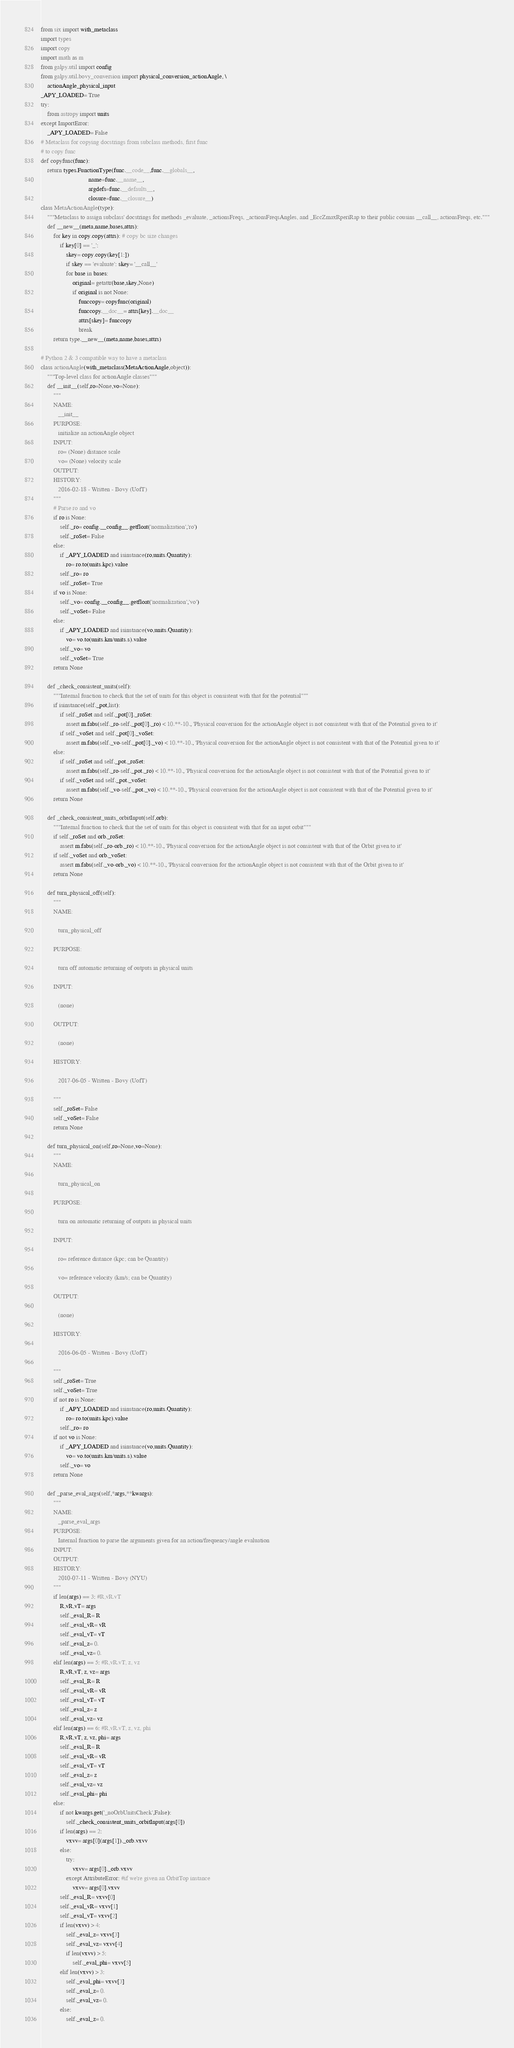Convert code to text. <code><loc_0><loc_0><loc_500><loc_500><_Python_>from six import with_metaclass
import types
import copy
import math as m
from galpy.util import config
from galpy.util.bovy_conversion import physical_conversion_actionAngle, \
    actionAngle_physical_input
_APY_LOADED= True
try:
    from astropy import units
except ImportError:
    _APY_LOADED= False
# Metaclass for copying docstrings from subclass methods, first func 
# to copy func
def copyfunc(func):
    return types.FunctionType(func.__code__,func.__globals__,
                              name=func.__name__,
                              argdefs=func.__defaults__,
                              closure=func.__closure__)
class MetaActionAngle(type):
    """Metaclass to assign subclass' docstrings for methods _evaluate, _actionsFreqs, _actionsFreqsAngles, and _EccZmaxRperiRap to their public cousins __call__, actionsFreqs, etc."""
    def __new__(meta,name,bases,attrs):
        for key in copy.copy(attrs): # copy bc size changes
            if key[0] == '_':
                skey= copy.copy(key[1:])
                if skey == 'evaluate': skey= '__call__'
                for base in bases:
                    original= getattr(base,skey,None)
                    if original is not None:
                        funccopy= copyfunc(original)
                        funccopy.__doc__= attrs[key].__doc__
                        attrs[skey]= funccopy
                        break
        return type.__new__(meta,name,bases,attrs)

# Python 2 & 3 compatible way to have a metaclass
class actionAngle(with_metaclass(MetaActionAngle,object)):
    """Top-level class for actionAngle classes"""
    def __init__(self,ro=None,vo=None):
        """
        NAME:
           __init__
        PURPOSE:
           initialize an actionAngle object
        INPUT:
           ro= (None) distance scale
           vo= (None) velocity scale
        OUTPUT:
        HISTORY:
           2016-02-18 - Written - Bovy (UofT)
        """
        # Parse ro and vo
        if ro is None:
            self._ro= config.__config__.getfloat('normalization','ro')
            self._roSet= False
        else:
            if _APY_LOADED and isinstance(ro,units.Quantity):
                ro= ro.to(units.kpc).value
            self._ro= ro
            self._roSet= True
        if vo is None:
            self._vo= config.__config__.getfloat('normalization','vo')
            self._voSet= False
        else:
            if _APY_LOADED and isinstance(vo,units.Quantity):
                vo= vo.to(units.km/units.s).value
            self._vo= vo
            self._voSet= True
        return None

    def _check_consistent_units(self):
        """Internal function to check that the set of units for this object is consistent with that for the potential"""
        if isinstance(self._pot,list):
            if self._roSet and self._pot[0]._roSet:
                assert m.fabs(self._ro-self._pot[0]._ro) < 10.**-10., 'Physical conversion for the actionAngle object is not consistent with that of the Potential given to it'
            if self._voSet and self._pot[0]._voSet:
                assert m.fabs(self._vo-self._pot[0]._vo) < 10.**-10., 'Physical conversion for the actionAngle object is not consistent with that of the Potential given to it'
        else:
            if self._roSet and self._pot._roSet:
                assert m.fabs(self._ro-self._pot._ro) < 10.**-10., 'Physical conversion for the actionAngle object is not consistent with that of the Potential given to it'
            if self._voSet and self._pot._voSet:
                assert m.fabs(self._vo-self._pot._vo) < 10.**-10., 'Physical conversion for the actionAngle object is not consistent with that of the Potential given to it'
        return None
            
    def _check_consistent_units_orbitInput(self,orb):
        """Internal function to check that the set of units for this object is consistent with that for an input orbit"""
        if self._roSet and orb._roSet:
            assert m.fabs(self._ro-orb._ro) < 10.**-10., 'Physical conversion for the actionAngle object is not consistent with that of the Orbit given to it'
        if self._voSet and orb._voSet:
            assert m.fabs(self._vo-orb._vo) < 10.**-10., 'Physical conversion for the actionAngle object is not consistent with that of the Orbit given to it'
        return None
            
    def turn_physical_off(self):
        """
        NAME:

           turn_physical_off

        PURPOSE:

           turn off automatic returning of outputs in physical units

        INPUT:

           (none)

        OUTPUT:

           (none)

        HISTORY:

           2017-06-05 - Written - Bovy (UofT)

        """
        self._roSet= False
        self._voSet= False
        return None

    def turn_physical_on(self,ro=None,vo=None):
        """
        NAME:

           turn_physical_on

        PURPOSE:

           turn on automatic returning of outputs in physical units

        INPUT:

           ro= reference distance (kpc; can be Quantity)

           vo= reference velocity (km/s; can be Quantity)

        OUTPUT:

           (none)

        HISTORY:

           2016-06-05 - Written - Bovy (UofT)

        """
        self._roSet= True
        self._voSet= True
        if not ro is None:
            if _APY_LOADED and isinstance(ro,units.Quantity):
                ro= ro.to(units.kpc).value
            self._ro= ro
        if not vo is None:
            if _APY_LOADED and isinstance(vo,units.Quantity):
                vo= vo.to(units.km/units.s).value
            self._vo= vo
        return None  

    def _parse_eval_args(self,*args,**kwargs):
        """
        NAME:
           _parse_eval_args
        PURPOSE:
           Internal function to parse the arguments given for an action/frequency/angle evaluation
        INPUT:
        OUTPUT:
        HISTORY:
           2010-07-11 - Written - Bovy (NYU)
        """
        if len(args) == 3: #R,vR.vT
            R,vR,vT= args
            self._eval_R= R
            self._eval_vR= vR
            self._eval_vT= vT
            self._eval_z= 0.
            self._eval_vz= 0.
        elif len(args) == 5: #R,vR.vT, z, vz
            R,vR,vT, z, vz= args
            self._eval_R= R
            self._eval_vR= vR
            self._eval_vT= vT
            self._eval_z= z
            self._eval_vz= vz
        elif len(args) == 6: #R,vR.vT, z, vz, phi
            R,vR,vT, z, vz, phi= args
            self._eval_R= R
            self._eval_vR= vR
            self._eval_vT= vT
            self._eval_z= z
            self._eval_vz= vz
            self._eval_phi= phi
        else:
            if not kwargs.get('_noOrbUnitsCheck',False):
                self._check_consistent_units_orbitInput(args[0])
            if len(args) == 2:
                vxvv= args[0](args[1])._orb.vxvv
            else:
                try:
                    vxvv= args[0]._orb.vxvv
                except AttributeError: #if we're given an OrbitTop instance
                    vxvv= args[0].vxvv
            self._eval_R= vxvv[0]
            self._eval_vR= vxvv[1]
            self._eval_vT= vxvv[2]
            if len(vxvv) > 4:
                self._eval_z= vxvv[3]
                self._eval_vz= vxvv[4]
                if len(vxvv) > 5:
                    self._eval_phi= vxvv[5]
            elif len(vxvv) > 3:
                self._eval_phi= vxvv[3]
                self._eval_z= 0.
                self._eval_vz= 0.
            else:
                self._eval_z= 0.</code> 